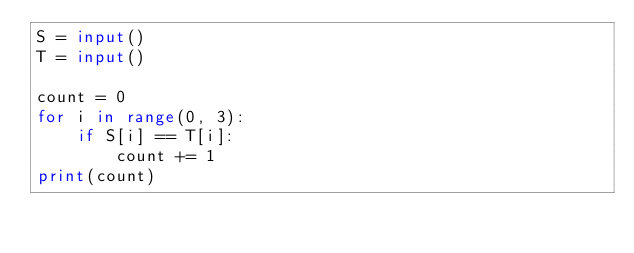<code> <loc_0><loc_0><loc_500><loc_500><_Python_>S = input()
T = input()

count = 0
for i in range(0, 3):
    if S[i] == T[i]:
        count += 1
print(count)</code> 